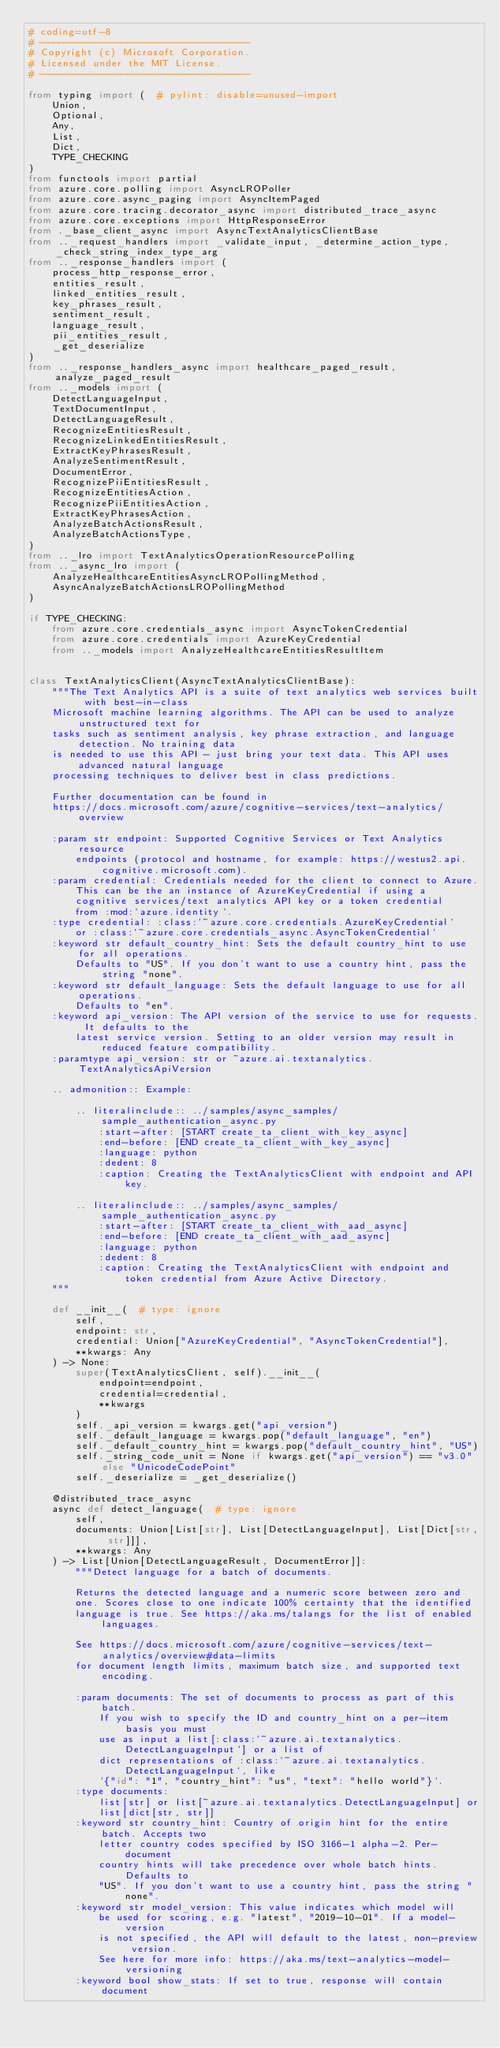Convert code to text. <code><loc_0><loc_0><loc_500><loc_500><_Python_># coding=utf-8
# ------------------------------------
# Copyright (c) Microsoft Corporation.
# Licensed under the MIT License.
# ------------------------------------

from typing import (  # pylint: disable=unused-import
    Union,
    Optional,
    Any,
    List,
    Dict,
    TYPE_CHECKING
)
from functools import partial
from azure.core.polling import AsyncLROPoller
from azure.core.async_paging import AsyncItemPaged
from azure.core.tracing.decorator_async import distributed_trace_async
from azure.core.exceptions import HttpResponseError
from ._base_client_async import AsyncTextAnalyticsClientBase
from .._request_handlers import _validate_input, _determine_action_type, _check_string_index_type_arg
from .._response_handlers import (
    process_http_response_error,
    entities_result,
    linked_entities_result,
    key_phrases_result,
    sentiment_result,
    language_result,
    pii_entities_result,
    _get_deserialize
)
from .._response_handlers_async import healthcare_paged_result, analyze_paged_result
from .._models import (
    DetectLanguageInput,
    TextDocumentInput,
    DetectLanguageResult,
    RecognizeEntitiesResult,
    RecognizeLinkedEntitiesResult,
    ExtractKeyPhrasesResult,
    AnalyzeSentimentResult,
    DocumentError,
    RecognizePiiEntitiesResult,
    RecognizeEntitiesAction,
    RecognizePiiEntitiesAction,
    ExtractKeyPhrasesAction,
    AnalyzeBatchActionsResult,
    AnalyzeBatchActionsType,
)
from .._lro import TextAnalyticsOperationResourcePolling
from .._async_lro import (
    AnalyzeHealthcareEntitiesAsyncLROPollingMethod,
    AsyncAnalyzeBatchActionsLROPollingMethod
)

if TYPE_CHECKING:
    from azure.core.credentials_async import AsyncTokenCredential
    from azure.core.credentials import AzureKeyCredential
    from .._models import AnalyzeHealthcareEntitiesResultItem


class TextAnalyticsClient(AsyncTextAnalyticsClientBase):
    """The Text Analytics API is a suite of text analytics web services built with best-in-class
    Microsoft machine learning algorithms. The API can be used to analyze unstructured text for
    tasks such as sentiment analysis, key phrase extraction, and language detection. No training data
    is needed to use this API - just bring your text data. This API uses advanced natural language
    processing techniques to deliver best in class predictions.

    Further documentation can be found in
    https://docs.microsoft.com/azure/cognitive-services/text-analytics/overview

    :param str endpoint: Supported Cognitive Services or Text Analytics resource
        endpoints (protocol and hostname, for example: https://westus2.api.cognitive.microsoft.com).
    :param credential: Credentials needed for the client to connect to Azure.
        This can be the an instance of AzureKeyCredential if using a
        cognitive services/text analytics API key or a token credential
        from :mod:`azure.identity`.
    :type credential: :class:`~azure.core.credentials.AzureKeyCredential`
        or :class:`~azure.core.credentials_async.AsyncTokenCredential`
    :keyword str default_country_hint: Sets the default country_hint to use for all operations.
        Defaults to "US". If you don't want to use a country hint, pass the string "none".
    :keyword str default_language: Sets the default language to use for all operations.
        Defaults to "en".
    :keyword api_version: The API version of the service to use for requests. It defaults to the
        latest service version. Setting to an older version may result in reduced feature compatibility.
    :paramtype api_version: str or ~azure.ai.textanalytics.TextAnalyticsApiVersion

    .. admonition:: Example:

        .. literalinclude:: ../samples/async_samples/sample_authentication_async.py
            :start-after: [START create_ta_client_with_key_async]
            :end-before: [END create_ta_client_with_key_async]
            :language: python
            :dedent: 8
            :caption: Creating the TextAnalyticsClient with endpoint and API key.

        .. literalinclude:: ../samples/async_samples/sample_authentication_async.py
            :start-after: [START create_ta_client_with_aad_async]
            :end-before: [END create_ta_client_with_aad_async]
            :language: python
            :dedent: 8
            :caption: Creating the TextAnalyticsClient with endpoint and token credential from Azure Active Directory.
    """

    def __init__(  # type: ignore
        self,
        endpoint: str,
        credential: Union["AzureKeyCredential", "AsyncTokenCredential"],
        **kwargs: Any
    ) -> None:
        super(TextAnalyticsClient, self).__init__(
            endpoint=endpoint,
            credential=credential,
            **kwargs
        )
        self._api_version = kwargs.get("api_version")
        self._default_language = kwargs.pop("default_language", "en")
        self._default_country_hint = kwargs.pop("default_country_hint", "US")
        self._string_code_unit = None if kwargs.get("api_version") == "v3.0" else "UnicodeCodePoint"
        self._deserialize = _get_deserialize()

    @distributed_trace_async
    async def detect_language(  # type: ignore
        self,
        documents: Union[List[str], List[DetectLanguageInput], List[Dict[str, str]]],
        **kwargs: Any
    ) -> List[Union[DetectLanguageResult, DocumentError]]:
        """Detect language for a batch of documents.

        Returns the detected language and a numeric score between zero and
        one. Scores close to one indicate 100% certainty that the identified
        language is true. See https://aka.ms/talangs for the list of enabled languages.

        See https://docs.microsoft.com/azure/cognitive-services/text-analytics/overview#data-limits
        for document length limits, maximum batch size, and supported text encoding.

        :param documents: The set of documents to process as part of this batch.
            If you wish to specify the ID and country_hint on a per-item basis you must
            use as input a list[:class:`~azure.ai.textanalytics.DetectLanguageInput`] or a list of
            dict representations of :class:`~azure.ai.textanalytics.DetectLanguageInput`, like
            `{"id": "1", "country_hint": "us", "text": "hello world"}`.
        :type documents:
            list[str] or list[~azure.ai.textanalytics.DetectLanguageInput] or
            list[dict[str, str]]
        :keyword str country_hint: Country of origin hint for the entire batch. Accepts two
            letter country codes specified by ISO 3166-1 alpha-2. Per-document
            country hints will take precedence over whole batch hints. Defaults to
            "US". If you don't want to use a country hint, pass the string "none".
        :keyword str model_version: This value indicates which model will
            be used for scoring, e.g. "latest", "2019-10-01". If a model-version
            is not specified, the API will default to the latest, non-preview version.
            See here for more info: https://aka.ms/text-analytics-model-versioning
        :keyword bool show_stats: If set to true, response will contain document</code> 